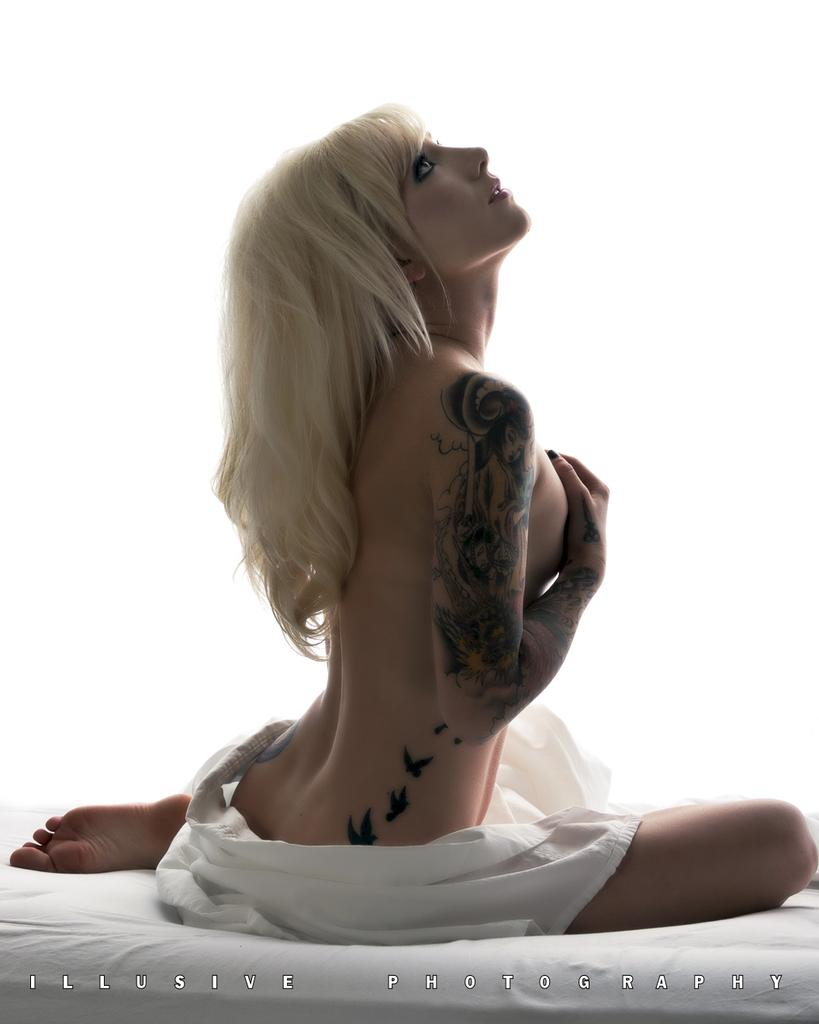Who is the main subject in the picture? There is a woman in the picture. What is the woman doing in the image? The woman is sitting on a bed. Can you describe the woman's appearance in the image? The woman is nude in the image. What is the color of the bed the woman is sitting on? The bed is white in color. How many mice can be seen playing with the woman's tail in the image? There are no mice or tails present in the image. 